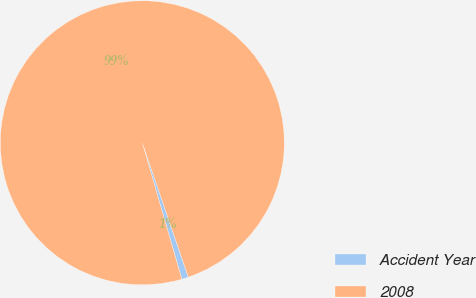Convert chart. <chart><loc_0><loc_0><loc_500><loc_500><pie_chart><fcel>Accident Year<fcel>2008<nl><fcel>0.76%<fcel>99.24%<nl></chart> 